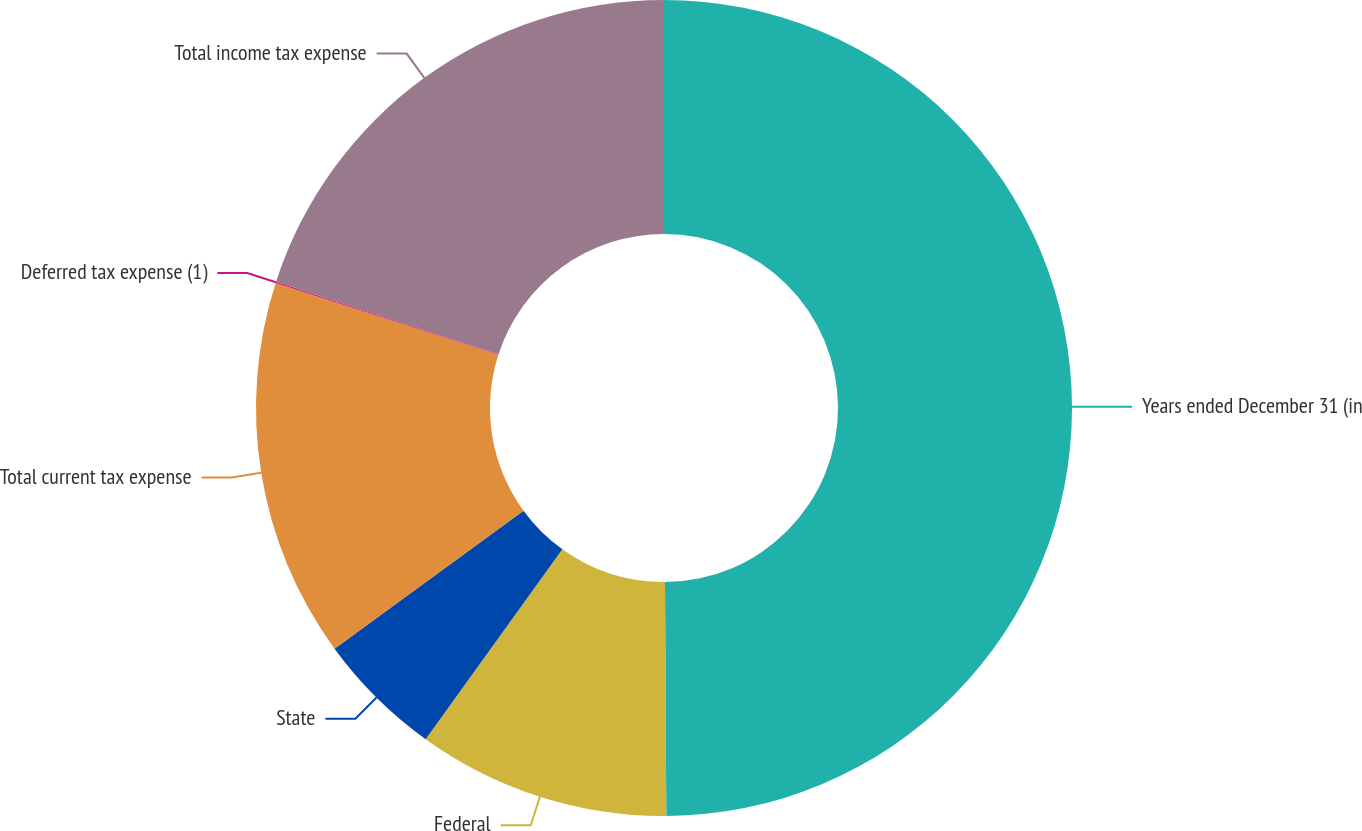Convert chart. <chart><loc_0><loc_0><loc_500><loc_500><pie_chart><fcel>Years ended December 31 (in<fcel>Federal<fcel>State<fcel>Total current tax expense<fcel>Deferred tax expense (1)<fcel>Total income tax expense<nl><fcel>49.91%<fcel>10.02%<fcel>5.03%<fcel>15.0%<fcel>0.05%<fcel>19.99%<nl></chart> 